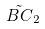Convert formula to latex. <formula><loc_0><loc_0><loc_500><loc_500>\tilde { B C } _ { 2 }</formula> 